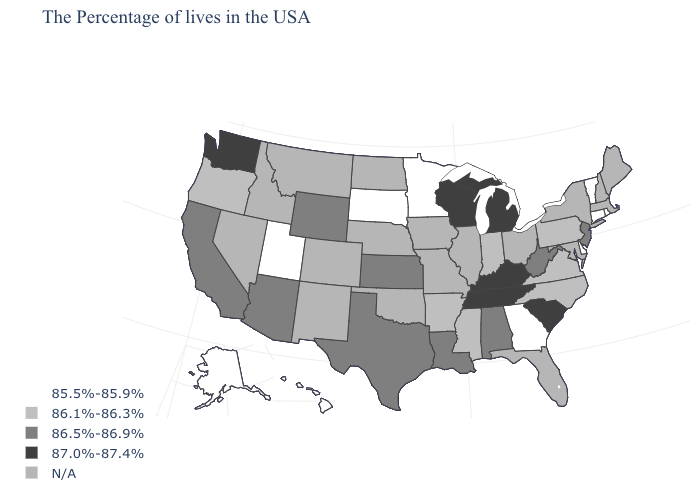Name the states that have a value in the range N/A?
Keep it brief. Maine, Massachusetts, New Hampshire, New York, Maryland, Ohio, Florida, Illinois, Missouri, Iowa, Nebraska, Oklahoma, North Dakota, Colorado, New Mexico, Montana, Idaho, Nevada. What is the value of Wisconsin?
Be succinct. 87.0%-87.4%. Does New Jersey have the highest value in the Northeast?
Give a very brief answer. Yes. What is the value of North Dakota?
Be succinct. N/A. Among the states that border Arkansas , which have the lowest value?
Keep it brief. Mississippi. Does Tennessee have the highest value in the USA?
Keep it brief. Yes. What is the value of Tennessee?
Keep it brief. 87.0%-87.4%. What is the value of Utah?
Keep it brief. 85.5%-85.9%. What is the lowest value in the USA?
Give a very brief answer. 85.5%-85.9%. Is the legend a continuous bar?
Write a very short answer. No. Does Washington have the highest value in the West?
Answer briefly. Yes. Name the states that have a value in the range 86.5%-86.9%?
Concise answer only. New Jersey, West Virginia, Alabama, Louisiana, Kansas, Texas, Wyoming, Arizona, California. Does the map have missing data?
Short answer required. Yes. What is the value of New Jersey?
Be succinct. 86.5%-86.9%. 